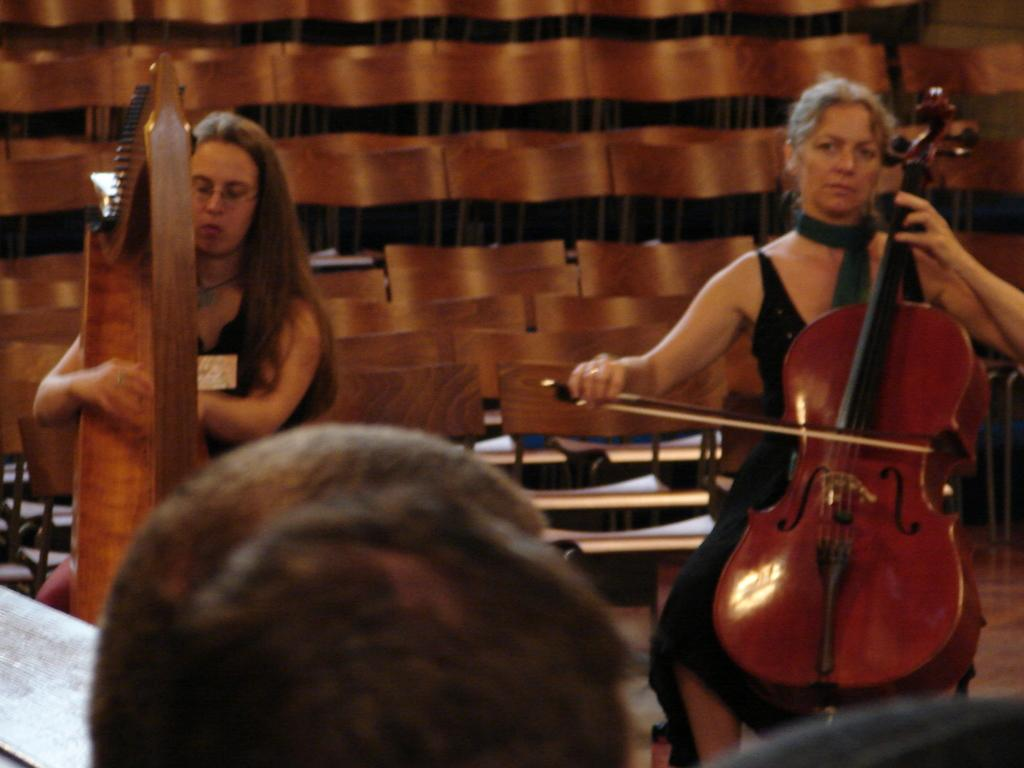How many people are present in the image? There are two people in the image. What are the two people doing? The two people are sitting and playing musical instruments. What can be seen in the background of the image? There are chairs in the background of the image. Is there anyone else visible in the image besides the two people playing instruments? Yes, there is a person at the bottom of the image. What type of cable is being used by the women in the image? There are no women present in the image, and no cables are visible. How many stockings are visible on the person at the bottom of the image? There is no mention of stockings in the image, and no such items are visible. 